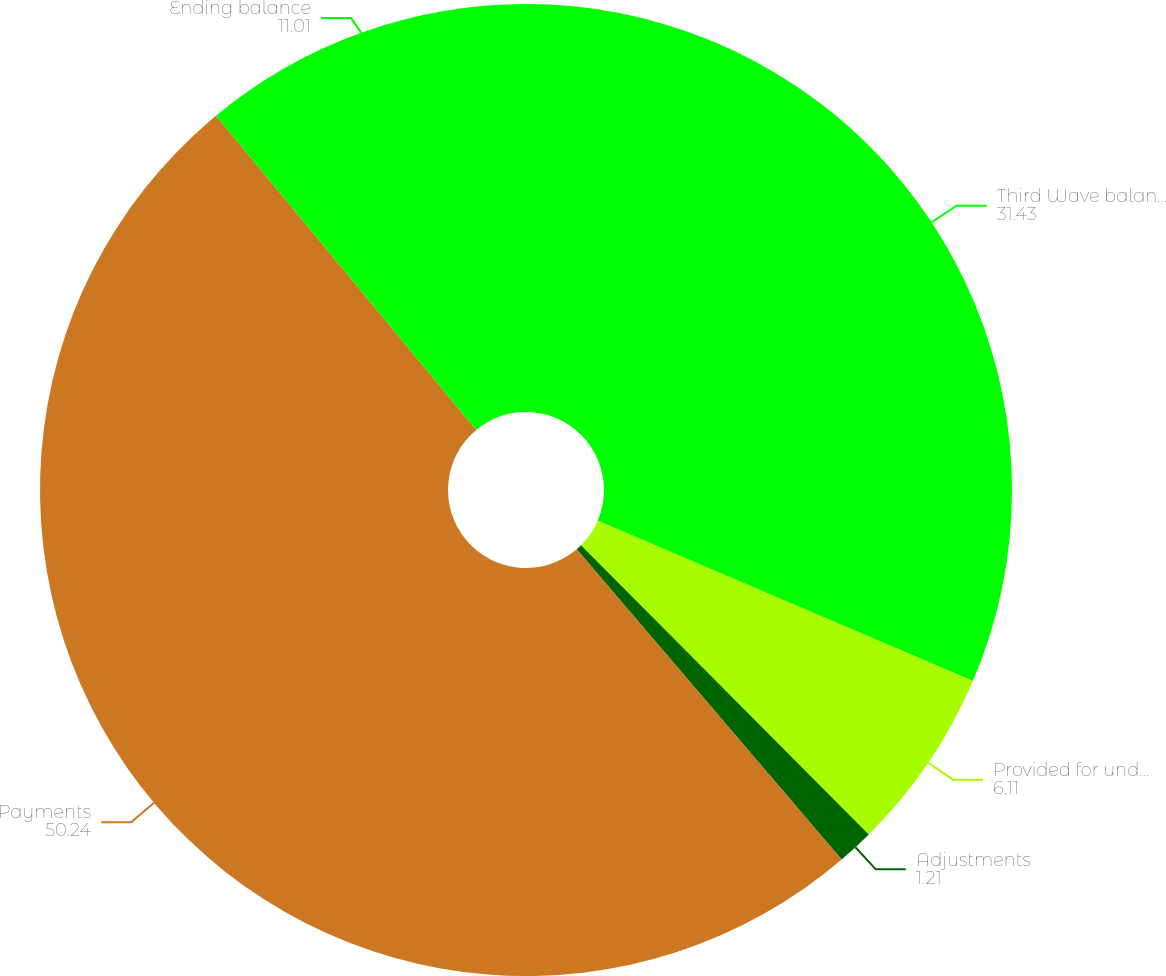<chart> <loc_0><loc_0><loc_500><loc_500><pie_chart><fcel>Third Wave balance acquired<fcel>Provided for under EITF No<fcel>Adjustments<fcel>Payments<fcel>Ending balance<nl><fcel>31.43%<fcel>6.11%<fcel>1.21%<fcel>50.24%<fcel>11.01%<nl></chart> 